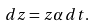Convert formula to latex. <formula><loc_0><loc_0><loc_500><loc_500>d z = z \alpha \, d t .</formula> 